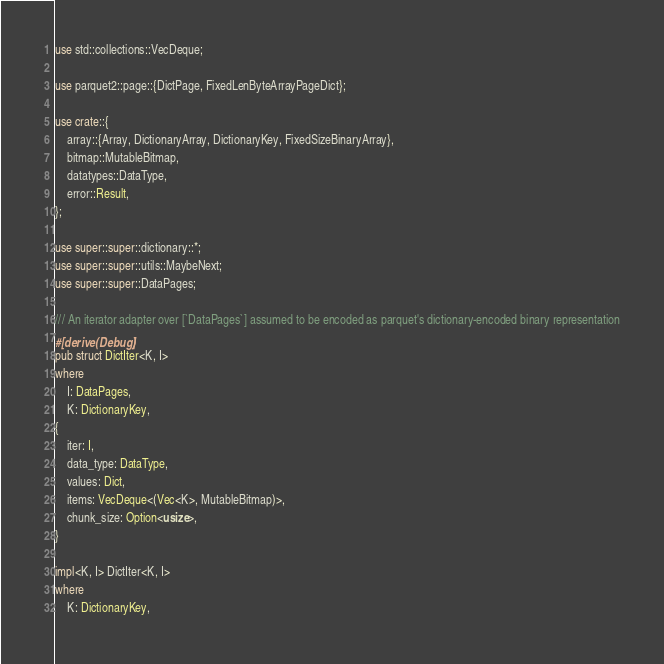Convert code to text. <code><loc_0><loc_0><loc_500><loc_500><_Rust_>use std::collections::VecDeque;

use parquet2::page::{DictPage, FixedLenByteArrayPageDict};

use crate::{
    array::{Array, DictionaryArray, DictionaryKey, FixedSizeBinaryArray},
    bitmap::MutableBitmap,
    datatypes::DataType,
    error::Result,
};

use super::super::dictionary::*;
use super::super::utils::MaybeNext;
use super::super::DataPages;

/// An iterator adapter over [`DataPages`] assumed to be encoded as parquet's dictionary-encoded binary representation
#[derive(Debug)]
pub struct DictIter<K, I>
where
    I: DataPages,
    K: DictionaryKey,
{
    iter: I,
    data_type: DataType,
    values: Dict,
    items: VecDeque<(Vec<K>, MutableBitmap)>,
    chunk_size: Option<usize>,
}

impl<K, I> DictIter<K, I>
where
    K: DictionaryKey,</code> 